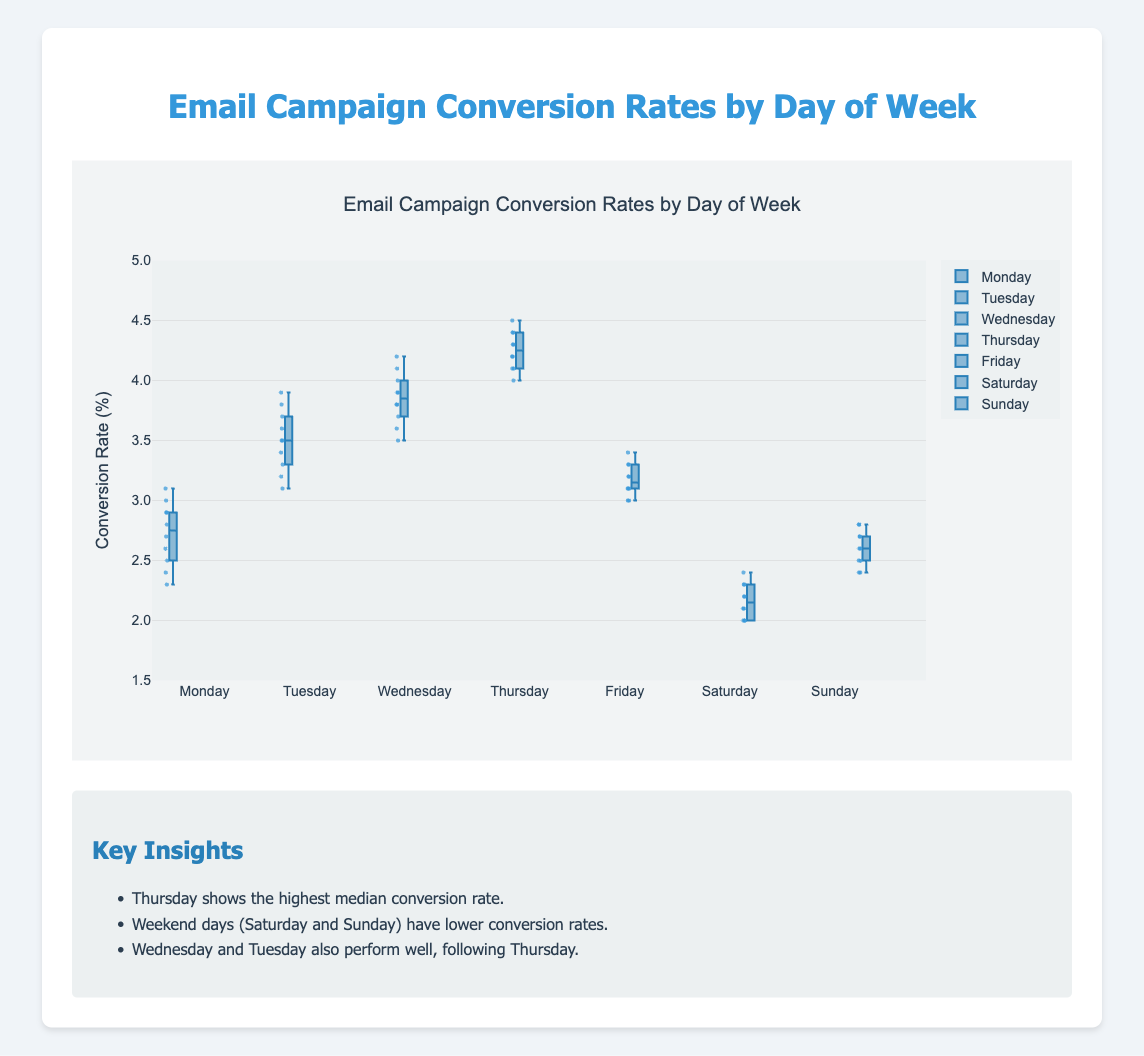What's the median conversion rate on Thursday? To find the median conversion rate on Thursday, look at the box plot for Thursday. The median is represented by the line inside the box.
Answer: 4.3 Which day has the highest overall conversion rates? From the box plots, the highest values are seen for Thursday, as the highest points on the graph reach up to around 4.5%.
Answer: Thursday How does the conversion rate on Saturdays compare to that on Wednesdays? Comparing the box plots, the conversion rates on Saturdays are lower than on Wednesdays. The median on Saturday is around 2.2% whereas on Wednesday it is around 3.9%.
Answer: Saturday < Wednesday What is the interquartile range (IQR) for Friday? The interquartile range (IQR) is the difference between the third quartile (Q3) and the first quartile (Q1). For Friday, estimate Q3 and Q1 from the box plot (around 3.3% and 3.1% respectively), then subtract Q1 from Q3. (3.3 - 3.1)
Answer: 0.2 Which day has the smallest spread in conversion rates? The spread can be visually determined by the length of the boxes in the plot. The smallest spread is on Friday, where the box (representing the interquartile range) is narrow compared to other days.
Answer: Friday What is the range of conversion rates on Monday? The range is determined by the difference between the maximum and minimum values in the box plot. For Monday, the values range from around 2.3% to 3.1%, so the range is (3.1 - 2.3).
Answer: 0.8 Which weekday has the lowest median conversion rate? To determine the weekday with the lowest median conversion rate, look at the median lines in the box plots of the weekdays (Monday to Friday). The lowest median value is on Monday, around 2.8%.
Answer: Monday On which day are conversion rates most consistent, and how do you know? Consistency can be judged by the narrowness of the box and the position of outliers if any. Friday has the narrowest box with less variation in data points, indicating the most consistent rates.
Answer: Friday 